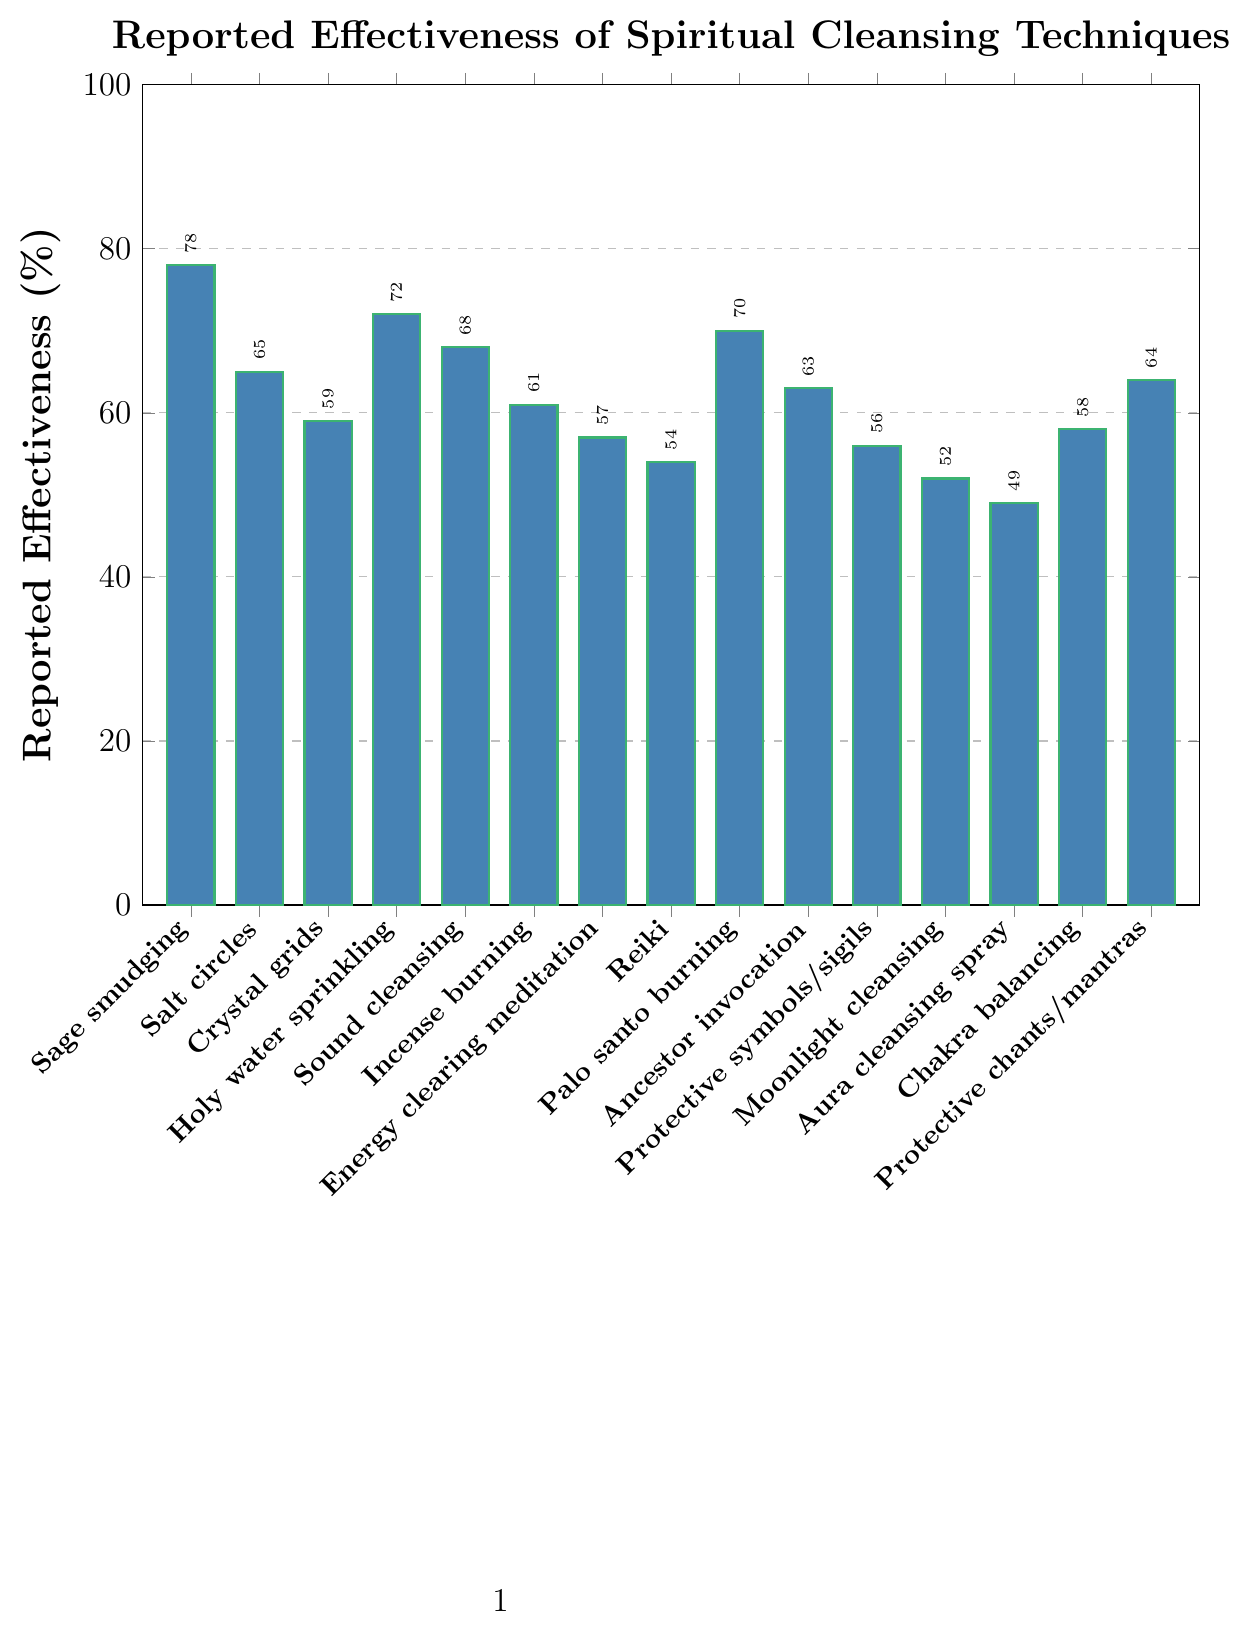Which technique has the highest reported effectiveness? The bar representing "Sage smudging" is the tallest among all bars, indicating it has the highest reported effectiveness.
Answer: Sage smudging Which technique has the lowest reported effectiveness? Observing the chart, the bar for "Aura cleansing spray" is the shortest, signifying the lowest reported effectiveness.
Answer: Aura cleansing spray How much more effective is Holy water sprinkling compared to Chakra balancing? The effectiveness of Holy water sprinkling is 72%, and Chakra balancing is 58%. Subtract 58 from 72 to find the difference. 72 - 58 = 14.
Answer: 14% Which two techniques have almost equal reported effectiveness and what are their values? The bars for "Incense burning" and "Crystal grids" are very close in height, indicating similar effectiveness values. Checking the chart, both values are around 61% and 59%, respectively.
Answer: Incense burning (61%) and Crystal grids (59%) What is the combined reported effectiveness of Sage smudging, Salt circles, and Protective chants/mantras? Add the reported effectiveness of Sage smudging (78%), Salt circles (65%), and Protective chants/mantras (64%). 78 + 65 + 64 = 207.
Answer: 207% Is the reported effectiveness of Reiki greater or less than Sound cleansing (bells/singing bowls)? Comparing the heights of the bars, Reiki's effectiveness is 54% and Sound cleansing's effectiveness is 68%. Therefore, Reiki is less effective.
Answer: Less What is the average reported effectiveness of the techniques related to burning (Sage smudging, Incense burning, and Palo santo burning)? The reported effectiveness values are Sage smudging (78%), Incense burning (61%), and Palo santo burning (70%). Compute their average: (78 + 61 + 70) / 3 = 69.67.
Answer: 69.67% How many techniques reported effectiveness below 60%? Count the bars that are below the 60% mark: Crystal grids (59%), Energy clearing meditation (57%), Reiki (54%), Moonlight cleansing (52%), Aura cleansing spray (49%). So, there are 5 techniques below 60%.
Answer: 5 What is the median value of the reported effectiveness for all techniques? Rank all effectiveness values in ascending order: 49, 52, 54, 56, 57, 58, 59, 61, 63, 64, 65, 68, 70, 72, 78. The middle value (8th in a list of 15) is 61, which represents the median.
Answer: 61% How does the effectiveness of Protective symbols/sigils compare to Ancestor invocation? Checking the bar heights, Protective symbols/sigils have an effectiveness of 56%, while Ancestor invocation is 63%. Therefore, Ancestor invocation is more effective.
Answer: Ancestor invocation more effective 